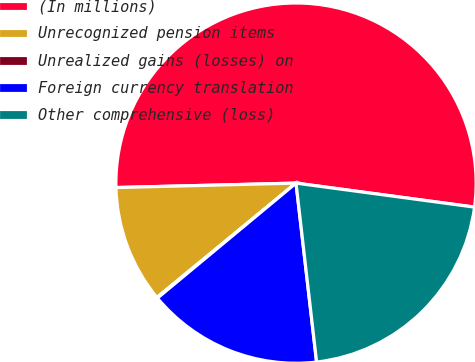<chart> <loc_0><loc_0><loc_500><loc_500><pie_chart><fcel>(In millions)<fcel>Unrecognized pension items<fcel>Unrealized gains (losses) on<fcel>Foreign currency translation<fcel>Other comprehensive (loss)<nl><fcel>52.52%<fcel>10.56%<fcel>0.07%<fcel>15.8%<fcel>21.05%<nl></chart> 